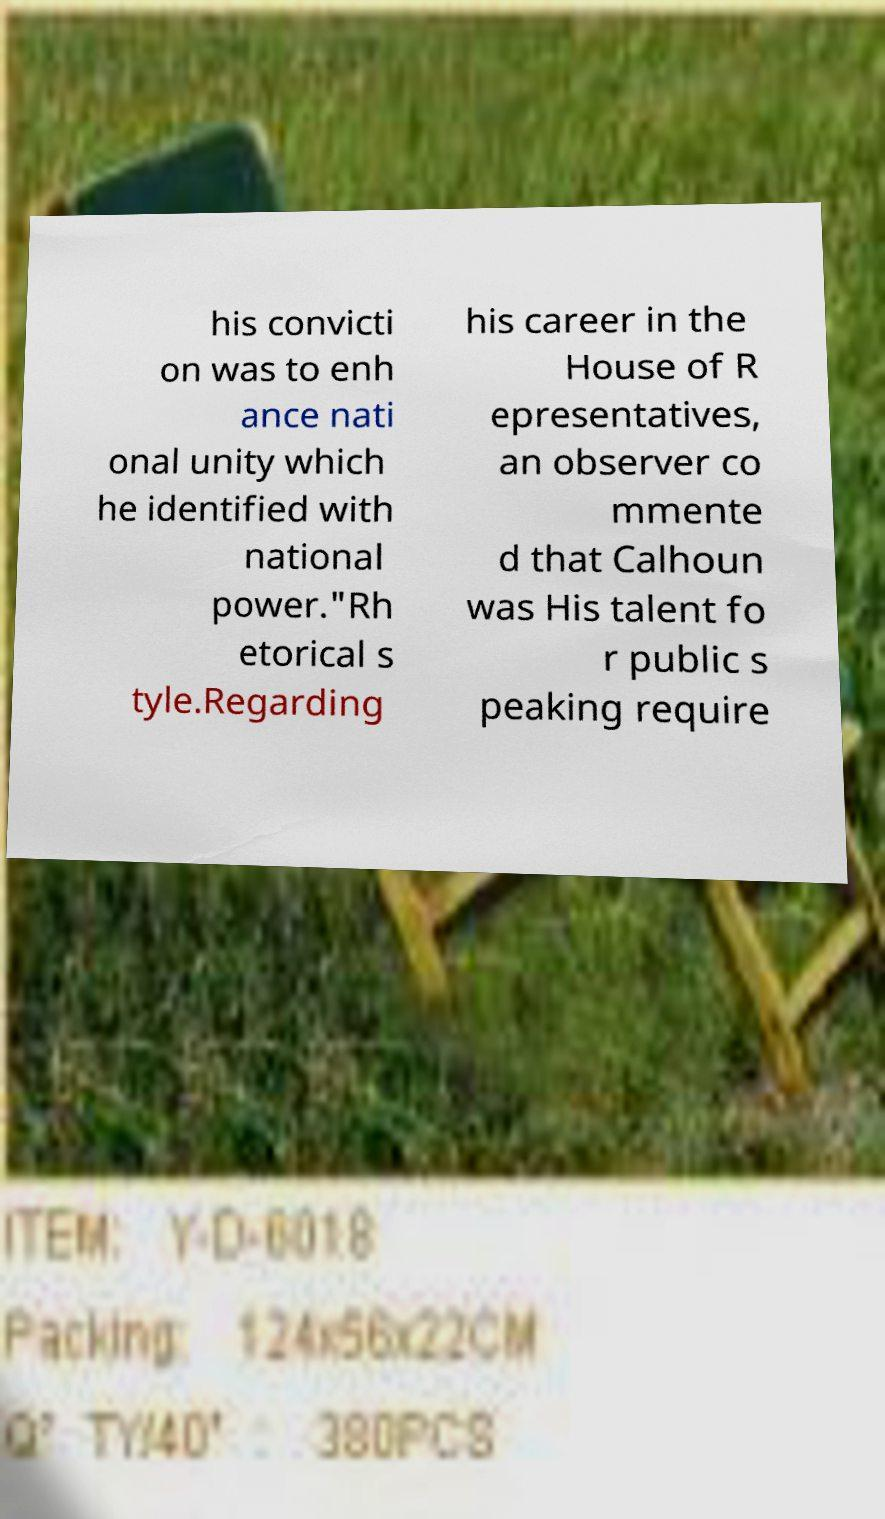Please read and relay the text visible in this image. What does it say? his convicti on was to enh ance nati onal unity which he identified with national power."Rh etorical s tyle.Regarding his career in the House of R epresentatives, an observer co mmente d that Calhoun was His talent fo r public s peaking require 